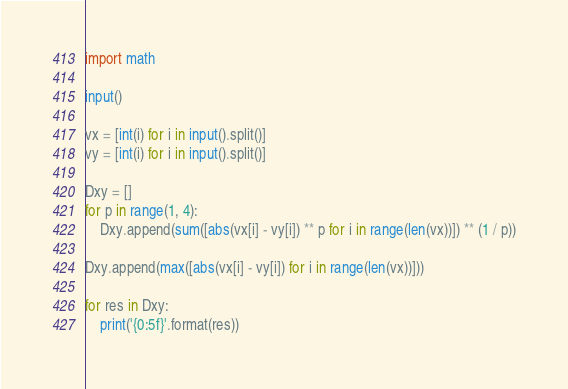Convert code to text. <code><loc_0><loc_0><loc_500><loc_500><_Python_>import math

input()

vx = [int(i) for i in input().split()]
vy = [int(i) for i in input().split()]

Dxy = []
for p in range(1, 4):
    Dxy.append(sum([abs(vx[i] - vy[i]) ** p for i in range(len(vx))]) ** (1 / p))

Dxy.append(max([abs(vx[i] - vy[i]) for i in range(len(vx))]))

for res in Dxy:
    print('{0:5f}'.format(res))</code> 